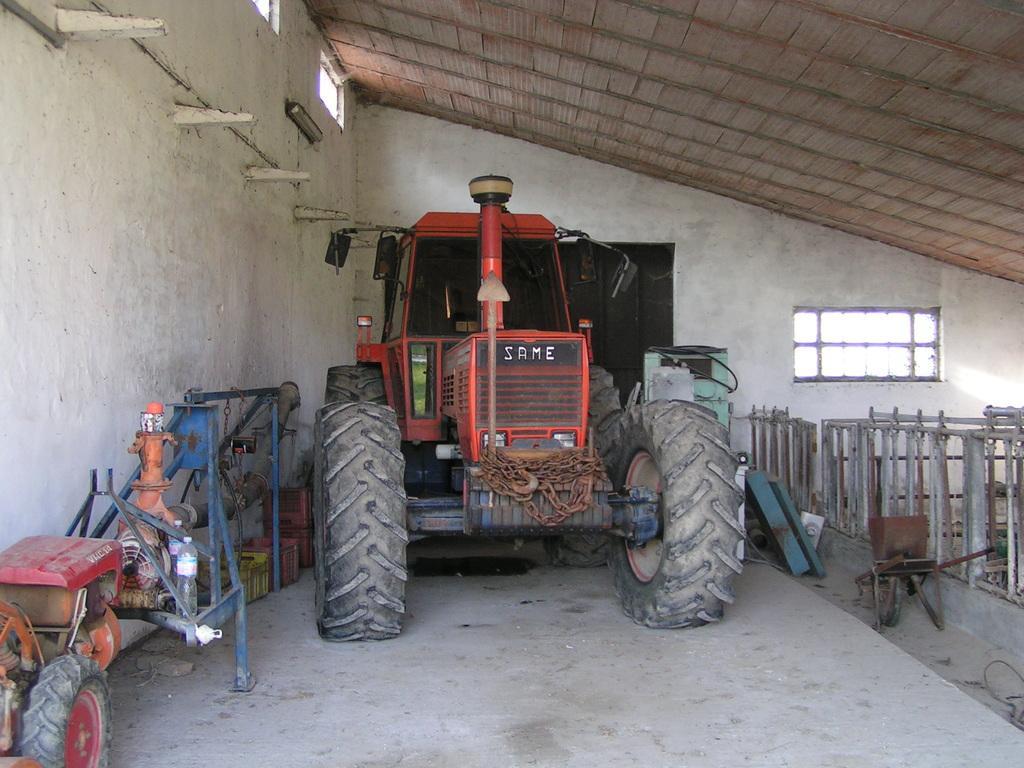Could you give a brief overview of what you see in this image? In this image, I can see a tractor. On the left side of the image, I can see mini tractor and baskets on the floor. On the right side of the image, there are few objects. In the background, there is a window to the wall. At the top of the image, I can see the ceiling and windows. 